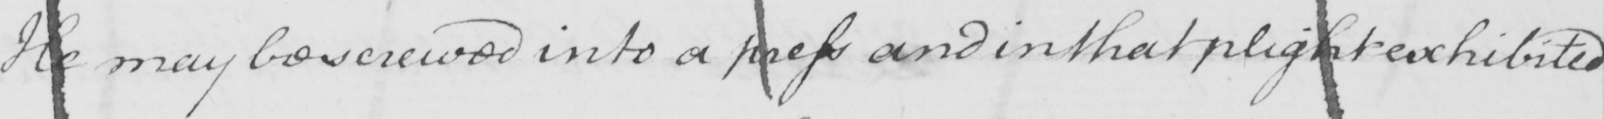Please transcribe the handwritten text in this image. He may be screwed into a press and in that plight exhibited 